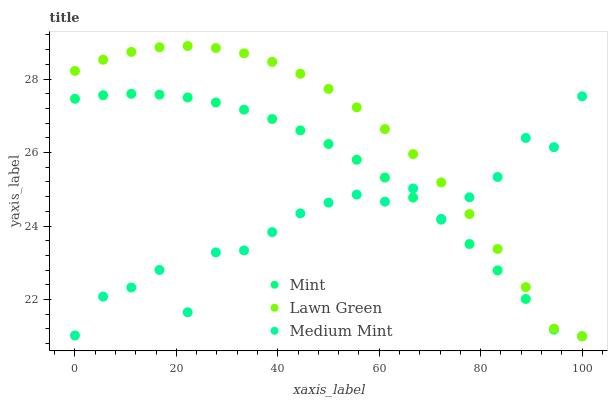Does Medium Mint have the minimum area under the curve?
Answer yes or no. Yes. Does Lawn Green have the maximum area under the curve?
Answer yes or no. Yes. Does Mint have the minimum area under the curve?
Answer yes or no. No. Does Mint have the maximum area under the curve?
Answer yes or no. No. Is Mint the smoothest?
Answer yes or no. Yes. Is Medium Mint the roughest?
Answer yes or no. Yes. Is Lawn Green the smoothest?
Answer yes or no. No. Is Lawn Green the roughest?
Answer yes or no. No. Does Lawn Green have the lowest value?
Answer yes or no. Yes. Does Lawn Green have the highest value?
Answer yes or no. Yes. Does Mint have the highest value?
Answer yes or no. No. Does Mint intersect Lawn Green?
Answer yes or no. Yes. Is Mint less than Lawn Green?
Answer yes or no. No. Is Mint greater than Lawn Green?
Answer yes or no. No. 